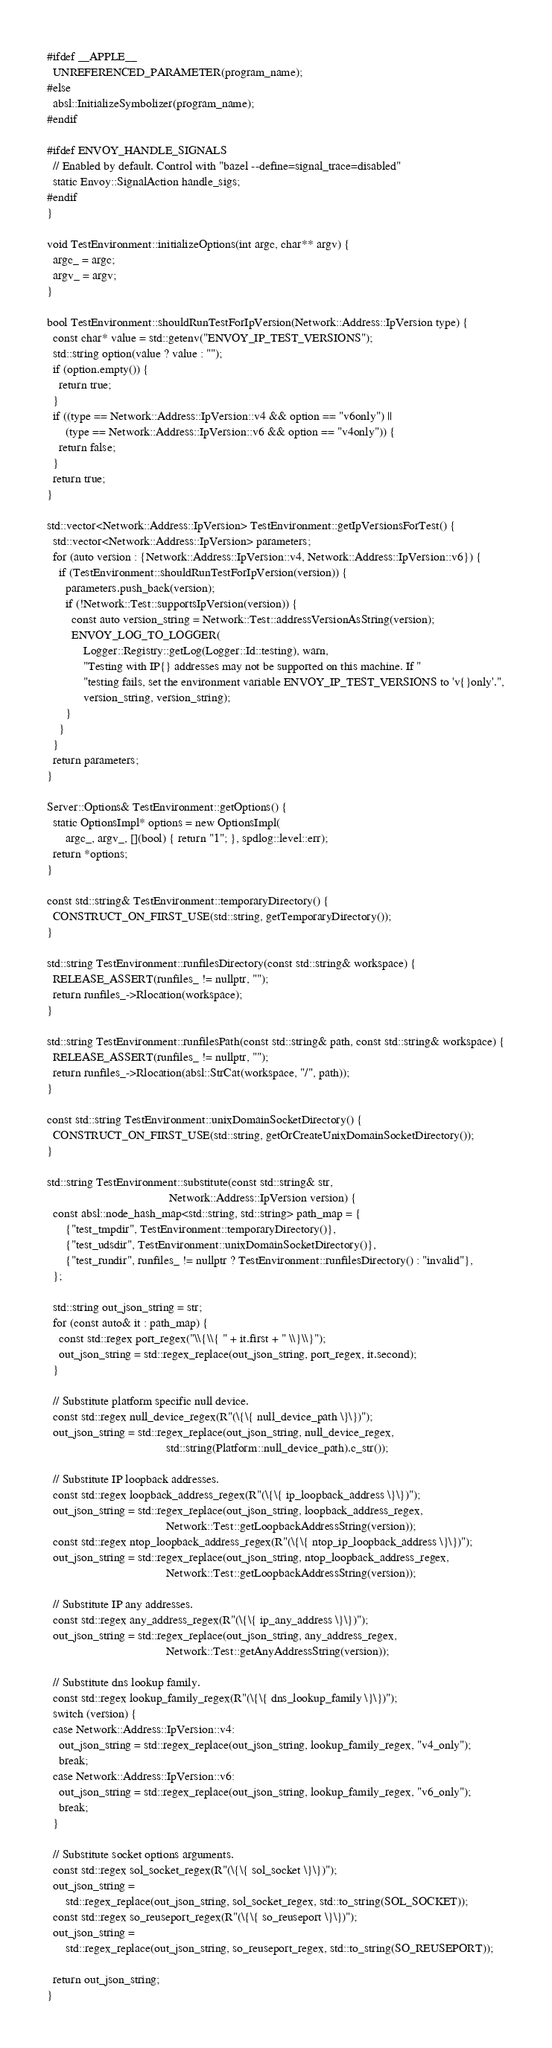<code> <loc_0><loc_0><loc_500><loc_500><_C++_>
#ifdef __APPLE__
  UNREFERENCED_PARAMETER(program_name);
#else
  absl::InitializeSymbolizer(program_name);
#endif

#ifdef ENVOY_HANDLE_SIGNALS
  // Enabled by default. Control with "bazel --define=signal_trace=disabled"
  static Envoy::SignalAction handle_sigs;
#endif
}

void TestEnvironment::initializeOptions(int argc, char** argv) {
  argc_ = argc;
  argv_ = argv;
}

bool TestEnvironment::shouldRunTestForIpVersion(Network::Address::IpVersion type) {
  const char* value = std::getenv("ENVOY_IP_TEST_VERSIONS");
  std::string option(value ? value : "");
  if (option.empty()) {
    return true;
  }
  if ((type == Network::Address::IpVersion::v4 && option == "v6only") ||
      (type == Network::Address::IpVersion::v6 && option == "v4only")) {
    return false;
  }
  return true;
}

std::vector<Network::Address::IpVersion> TestEnvironment::getIpVersionsForTest() {
  std::vector<Network::Address::IpVersion> parameters;
  for (auto version : {Network::Address::IpVersion::v4, Network::Address::IpVersion::v6}) {
    if (TestEnvironment::shouldRunTestForIpVersion(version)) {
      parameters.push_back(version);
      if (!Network::Test::supportsIpVersion(version)) {
        const auto version_string = Network::Test::addressVersionAsString(version);
        ENVOY_LOG_TO_LOGGER(
            Logger::Registry::getLog(Logger::Id::testing), warn,
            "Testing with IP{} addresses may not be supported on this machine. If "
            "testing fails, set the environment variable ENVOY_IP_TEST_VERSIONS to 'v{}only'.",
            version_string, version_string);
      }
    }
  }
  return parameters;
}

Server::Options& TestEnvironment::getOptions() {
  static OptionsImpl* options = new OptionsImpl(
      argc_, argv_, [](bool) { return "1"; }, spdlog::level::err);
  return *options;
}

const std::string& TestEnvironment::temporaryDirectory() {
  CONSTRUCT_ON_FIRST_USE(std::string, getTemporaryDirectory());
}

std::string TestEnvironment::runfilesDirectory(const std::string& workspace) {
  RELEASE_ASSERT(runfiles_ != nullptr, "");
  return runfiles_->Rlocation(workspace);
}

std::string TestEnvironment::runfilesPath(const std::string& path, const std::string& workspace) {
  RELEASE_ASSERT(runfiles_ != nullptr, "");
  return runfiles_->Rlocation(absl::StrCat(workspace, "/", path));
}

const std::string TestEnvironment::unixDomainSocketDirectory() {
  CONSTRUCT_ON_FIRST_USE(std::string, getOrCreateUnixDomainSocketDirectory());
}

std::string TestEnvironment::substitute(const std::string& str,
                                        Network::Address::IpVersion version) {
  const absl::node_hash_map<std::string, std::string> path_map = {
      {"test_tmpdir", TestEnvironment::temporaryDirectory()},
      {"test_udsdir", TestEnvironment::unixDomainSocketDirectory()},
      {"test_rundir", runfiles_ != nullptr ? TestEnvironment::runfilesDirectory() : "invalid"},
  };

  std::string out_json_string = str;
  for (const auto& it : path_map) {
    const std::regex port_regex("\\{\\{ " + it.first + " \\}\\}");
    out_json_string = std::regex_replace(out_json_string, port_regex, it.second);
  }

  // Substitute platform specific null device.
  const std::regex null_device_regex(R"(\{\{ null_device_path \}\})");
  out_json_string = std::regex_replace(out_json_string, null_device_regex,
                                       std::string(Platform::null_device_path).c_str());

  // Substitute IP loopback addresses.
  const std::regex loopback_address_regex(R"(\{\{ ip_loopback_address \}\})");
  out_json_string = std::regex_replace(out_json_string, loopback_address_regex,
                                       Network::Test::getLoopbackAddressString(version));
  const std::regex ntop_loopback_address_regex(R"(\{\{ ntop_ip_loopback_address \}\})");
  out_json_string = std::regex_replace(out_json_string, ntop_loopback_address_regex,
                                       Network::Test::getLoopbackAddressString(version));

  // Substitute IP any addresses.
  const std::regex any_address_regex(R"(\{\{ ip_any_address \}\})");
  out_json_string = std::regex_replace(out_json_string, any_address_regex,
                                       Network::Test::getAnyAddressString(version));

  // Substitute dns lookup family.
  const std::regex lookup_family_regex(R"(\{\{ dns_lookup_family \}\})");
  switch (version) {
  case Network::Address::IpVersion::v4:
    out_json_string = std::regex_replace(out_json_string, lookup_family_regex, "v4_only");
    break;
  case Network::Address::IpVersion::v6:
    out_json_string = std::regex_replace(out_json_string, lookup_family_regex, "v6_only");
    break;
  }

  // Substitute socket options arguments.
  const std::regex sol_socket_regex(R"(\{\{ sol_socket \}\})");
  out_json_string =
      std::regex_replace(out_json_string, sol_socket_regex, std::to_string(SOL_SOCKET));
  const std::regex so_reuseport_regex(R"(\{\{ so_reuseport \}\})");
  out_json_string =
      std::regex_replace(out_json_string, so_reuseport_regex, std::to_string(SO_REUSEPORT));

  return out_json_string;
}
</code> 